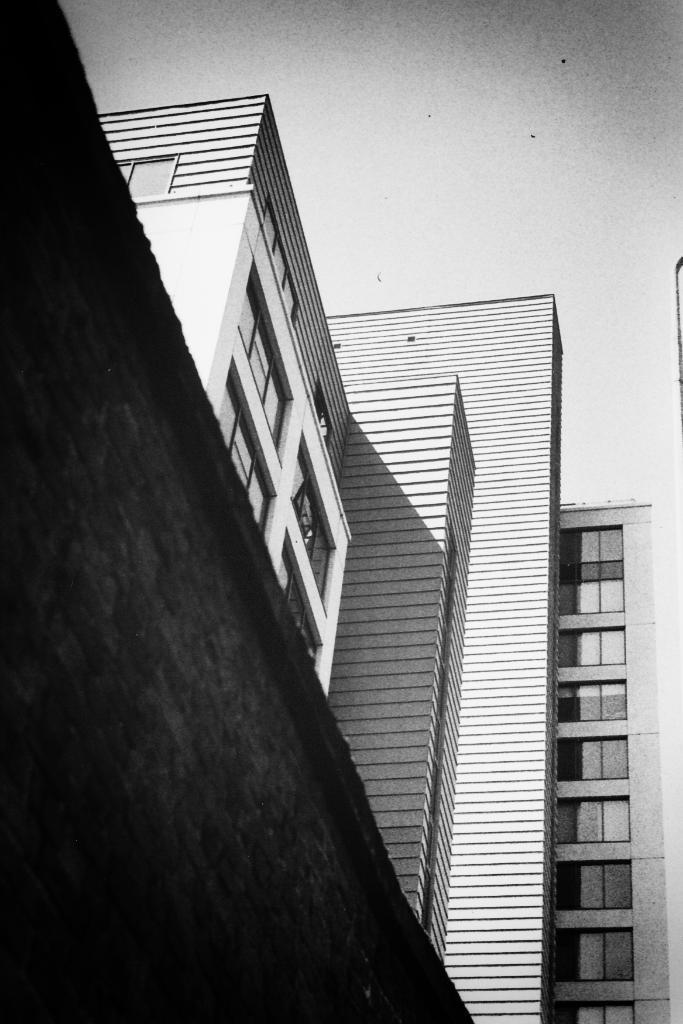Could you give a brief overview of what you see in this image? This is a black and white picture, in this image we can see a few buildings with windows, on the left side of the image it looks like the wall and in the background we can see the sky. 